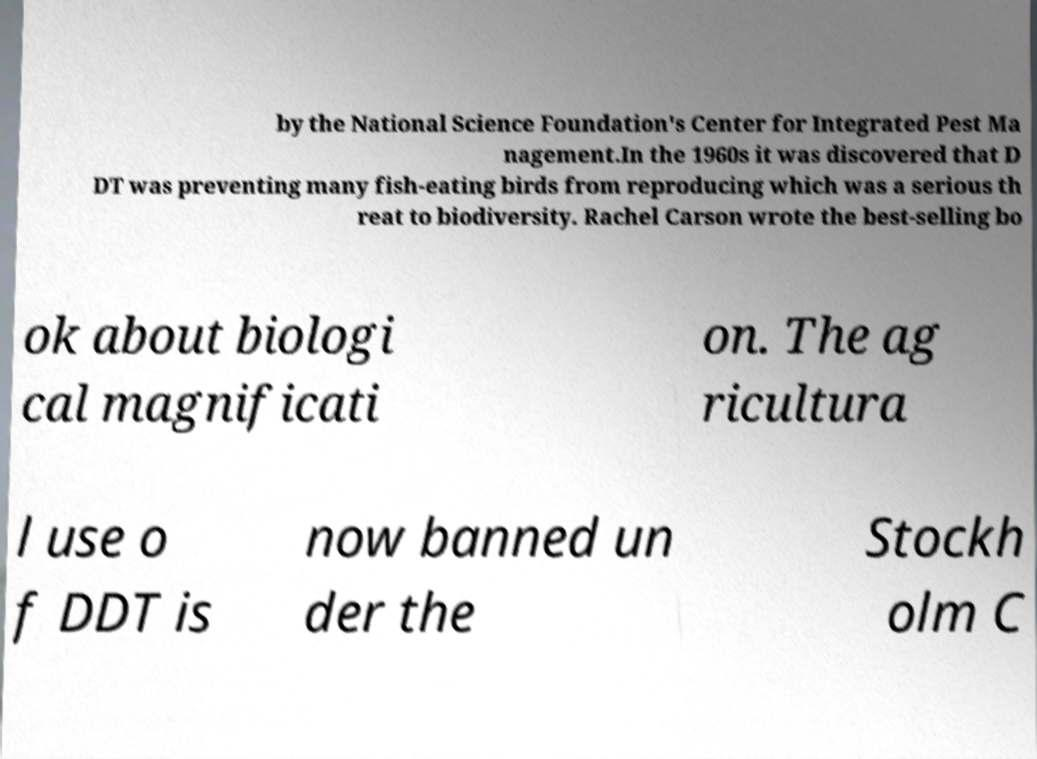Please identify and transcribe the text found in this image. by the National Science Foundation's Center for Integrated Pest Ma nagement.In the 1960s it was discovered that D DT was preventing many fish-eating birds from reproducing which was a serious th reat to biodiversity. Rachel Carson wrote the best-selling bo ok about biologi cal magnificati on. The ag ricultura l use o f DDT is now banned un der the Stockh olm C 